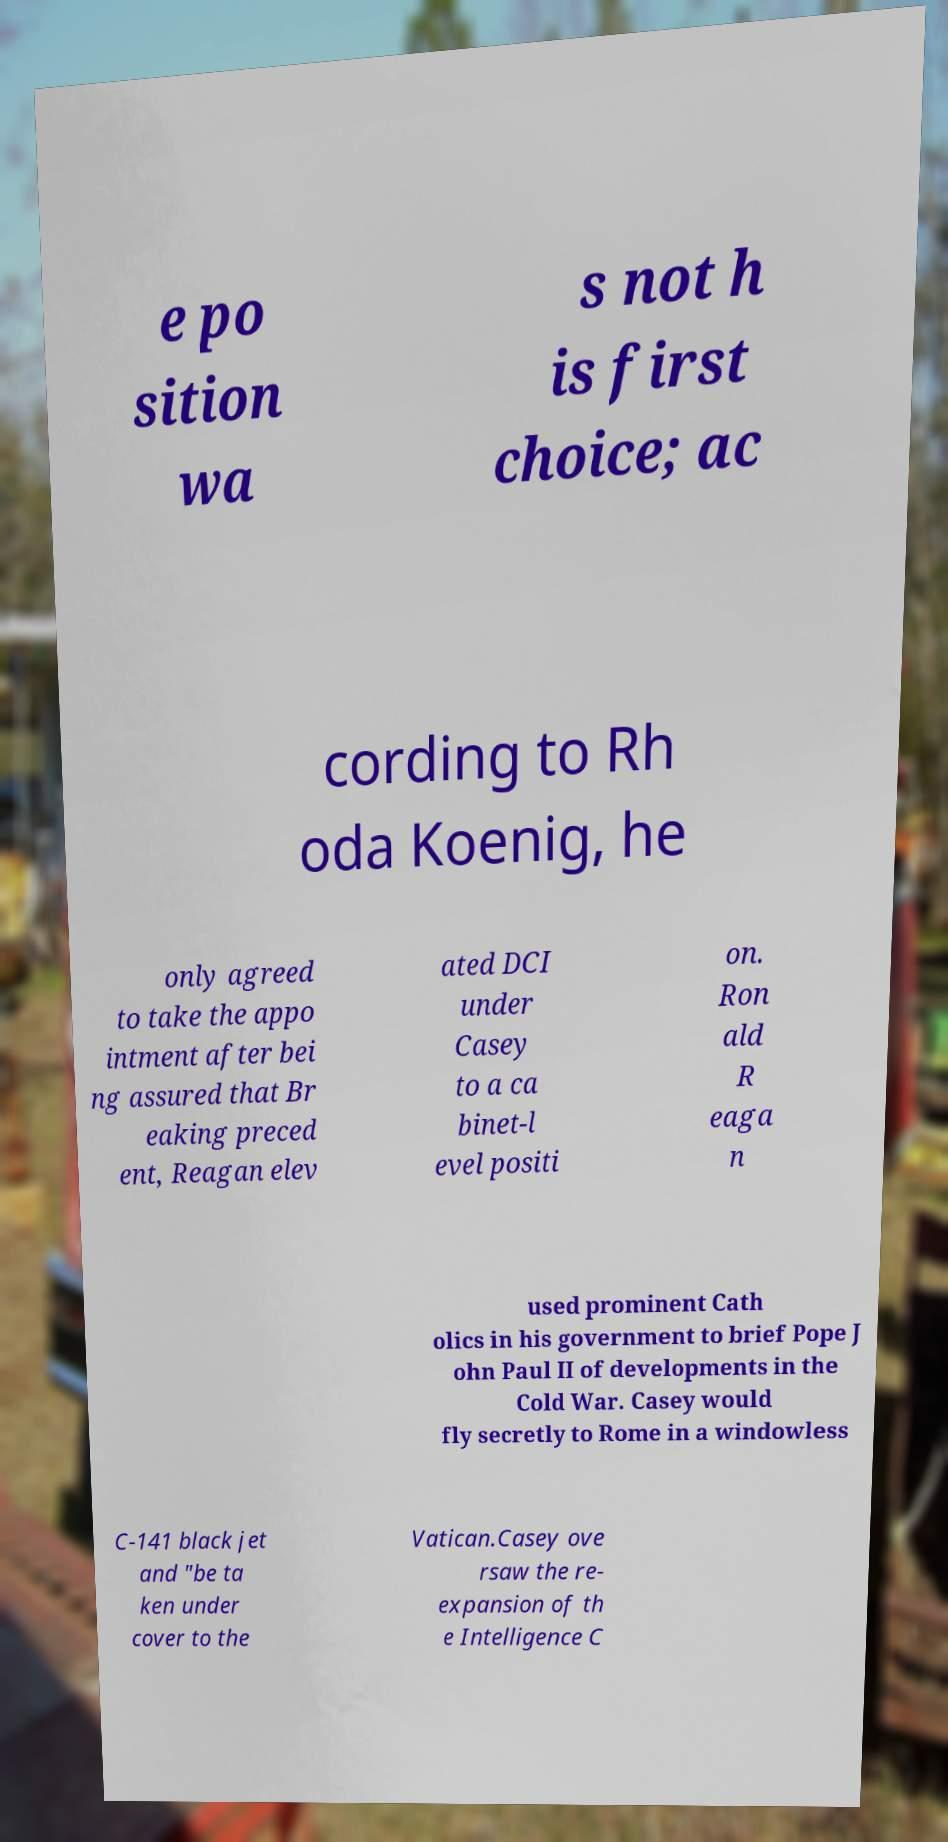Please identify and transcribe the text found in this image. e po sition wa s not h is first choice; ac cording to Rh oda Koenig, he only agreed to take the appo intment after bei ng assured that Br eaking preced ent, Reagan elev ated DCI under Casey to a ca binet-l evel positi on. Ron ald R eaga n used prominent Cath olics in his government to brief Pope J ohn Paul II of developments in the Cold War. Casey would fly secretly to Rome in a windowless C-141 black jet and "be ta ken under cover to the Vatican.Casey ove rsaw the re- expansion of th e Intelligence C 